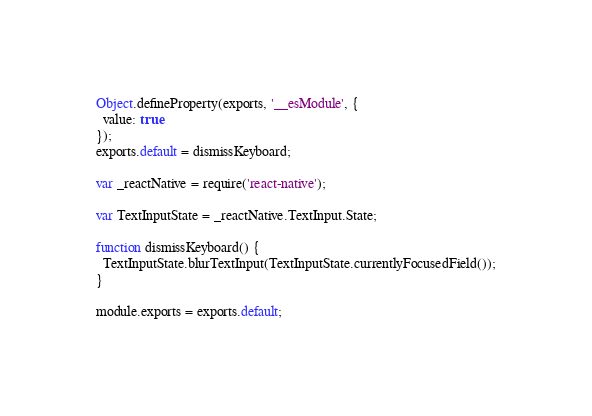<code> <loc_0><loc_0><loc_500><loc_500><_JavaScript_>Object.defineProperty(exports, '__esModule', {
  value: true
});
exports.default = dismissKeyboard;

var _reactNative = require('react-native');

var TextInputState = _reactNative.TextInput.State;

function dismissKeyboard() {
  TextInputState.blurTextInput(TextInputState.currentlyFocusedField());
}

module.exports = exports.default;</code> 